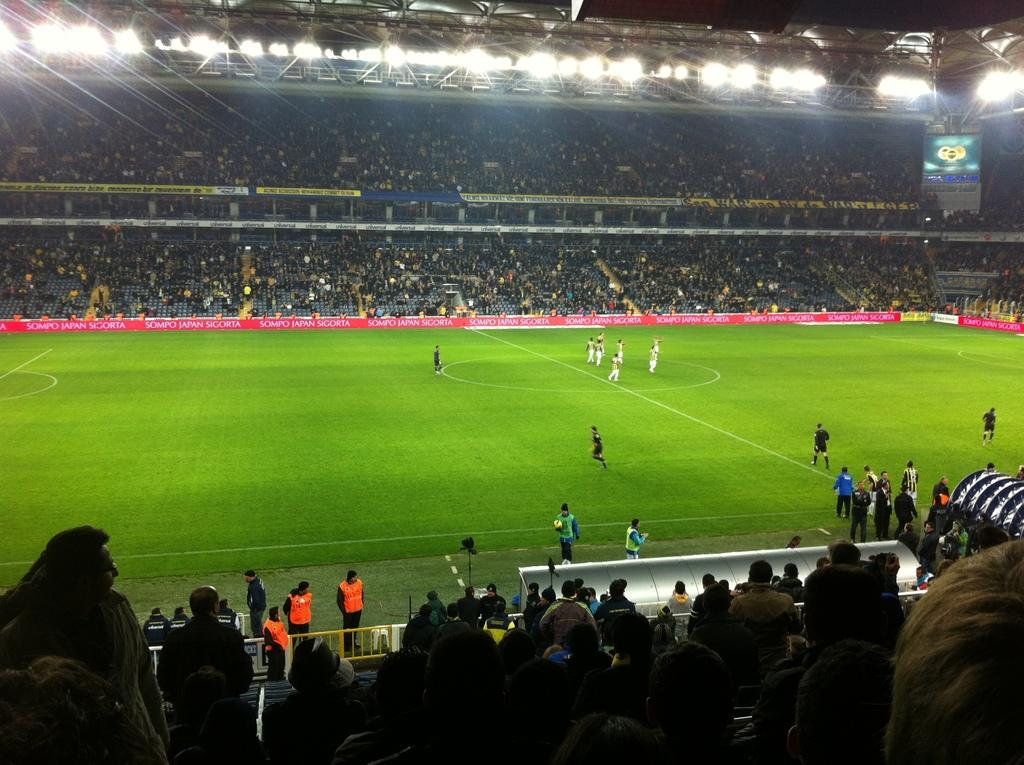What type of location is depicted in the image? The image shows the interior view of a stadium. What can be seen on the ground in the image? There is a ground with objects in the image. Are there any people present in the image? Yes, there are people present in the image. What is written on the boards in the image? There are boards with text in the image. What can be used to illuminate the area in the image? There are lights visible in the image. What type of display device is present in the image? There is a screen in the image. What type of government is in power during the minute shown in the image? The image does not provide any information about the government or the time duration, so it is not possible to answer this question. 